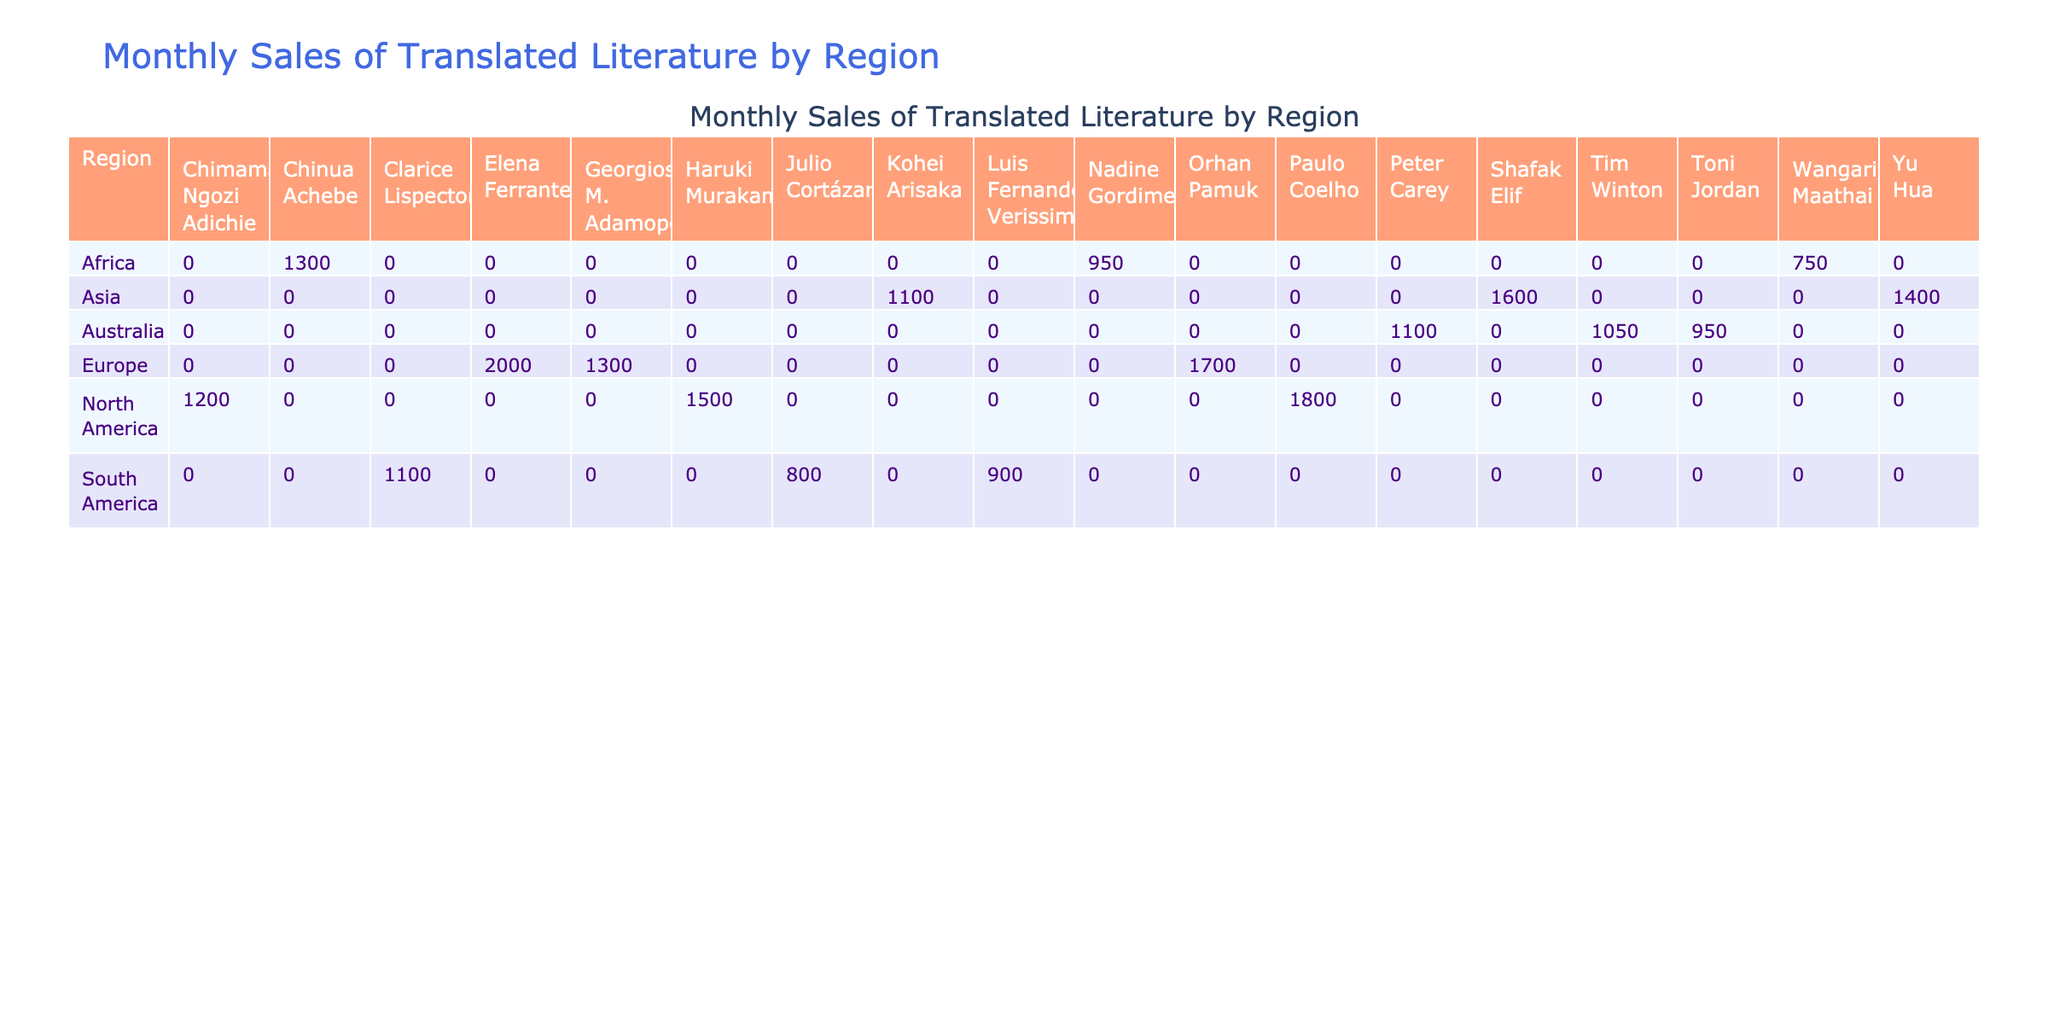What is the total sales of translated literature in North America? To find the total sales in North America, we add the sales figures for each author in that region: Haruki Murakami (1500) + Chimamanda Ngozi Adichie (1200) + Paulo Coelho (1800). This gives us a total of 1500 + 1200 + 1800 = 4500.
Answer: 4500 Which author had the highest sales in Europe? In the Europe region, the sales figures are: Elena Ferrante (2000), Orhan Pamuk (1700), and Georgios M. Adamopoulos (1300). The highest sales figure is from Elena Ferrante at 2000.
Answer: Elena Ferrante How many authors are listed from South America? The authors from South America are: Luis Fernando Verissimo, Julio Cortázar, and Clarice Lispector, which makes a total of 3 authors listed for that region.
Answer: 3 What are the combined sales of translated literature in Asia? To find the total sales in Asia, we add the individual sales for each author: Yu Hua (1400) + Shafak Elif (1600) + Kohei Arisaka (1100). Therefore, the total is 1400 + 1600 + 1100 = 4100.
Answer: 4100 Is there an author from Africa with sales greater than 1000? Checking the sales figures for African authors: Nadine Gordimer (950), Wangari Maathai (750), and Chinua Achebe (1300). Among these, Chinua Achebe has sales of 1300, which is greater than 1000, confirming the statement is true.
Answer: Yes Which region has the lowest total sales figures? The total sales for each region are calculated as follows: North America (4500), Europe (5000), Asia (4100), South America (2800), Africa (1970), and Australia (3100). Comparing these, South America has the lowest total sales figures at 2800.
Answer: South America What is the average sales per author in Australia? There are three authors from Australia: Peter Carey (1100), Toni Jordan (950), and Tim Winton (1050). First, we sum their sales: 1100 + 950 + 1050 = 3100. Then, we divide by the number of authors, which is 3: 3100 / 3 = 1033.33.
Answer: 1033.33 Which region has more authors: North America or Africa? North America has three authors (Murakami, Adichie, Coelho), while Africa has three authors as well (Gordimer, Maathai, Achebe). Since both regions have an equal number of authors, we determine that neither region has more authors.
Answer: Neither What is the difference in sales between the highest and lowest author sales in Europe? The highest sales in Europe is by Elena Ferrante with 2000, while the lowest is Georgios M. Adamopoulos with 1300. The difference is calculated as: 2000 - 1300 = 700.
Answer: 700 